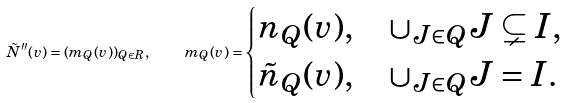Convert formula to latex. <formula><loc_0><loc_0><loc_500><loc_500>\tilde { N } ^ { \prime \prime } ( v ) = ( m _ { Q } ( v ) ) _ { Q \in R } , \quad m _ { Q } ( v ) = \begin{cases} n _ { Q } ( v ) , & \cup _ { J \in Q } J \subsetneq I , \\ \tilde { n } _ { Q } ( v ) , & \cup _ { J \in Q } J = I . \end{cases}</formula> 